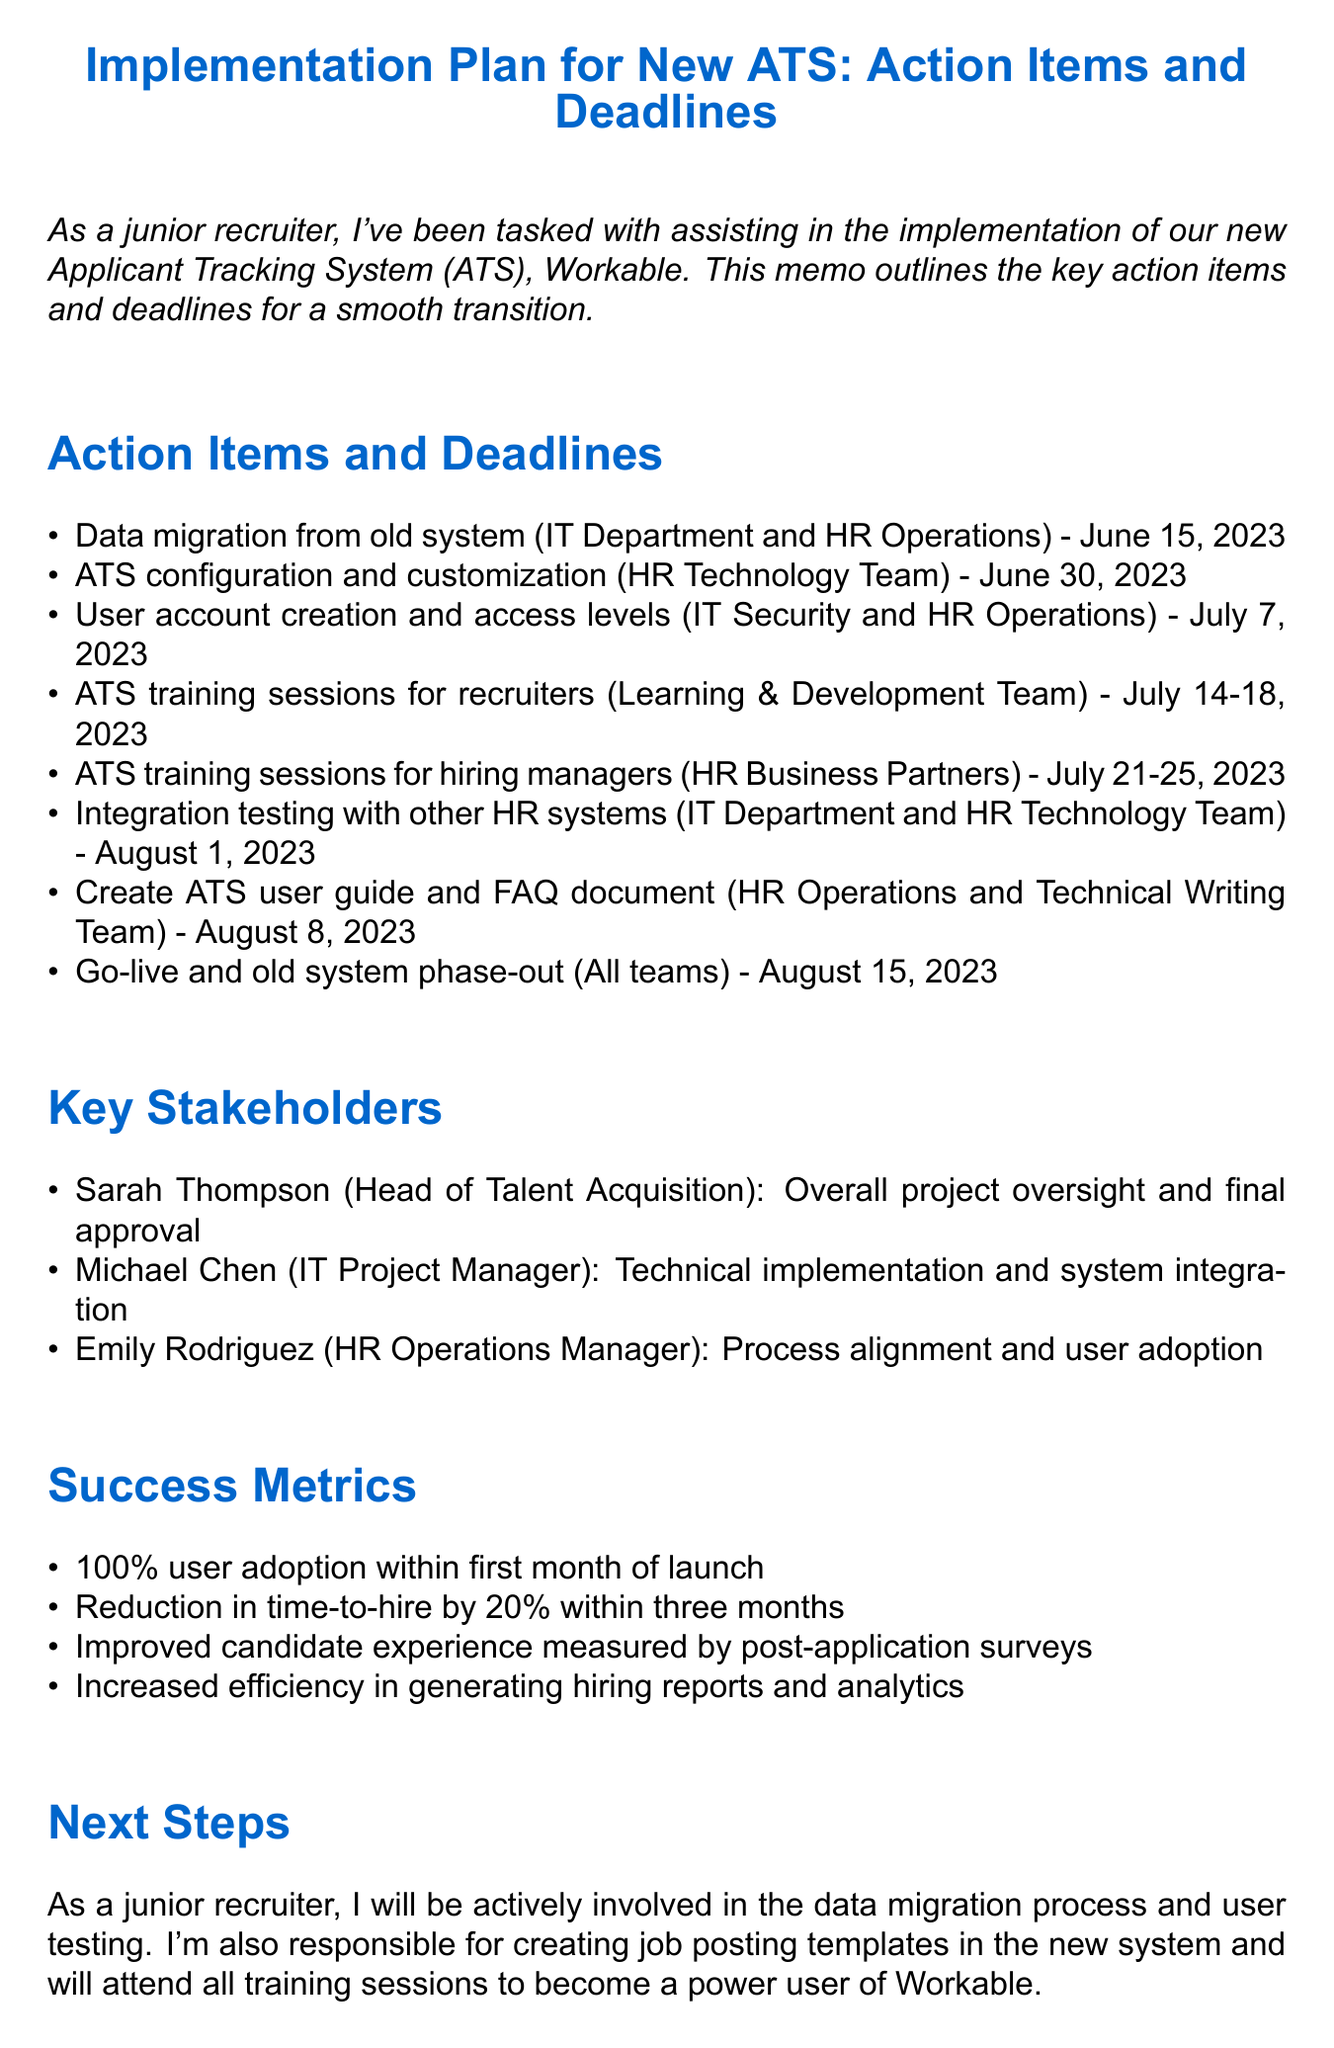What is the title of the memo? The title of the memo is presented at the beginning of the document as the main heading.
Answer: Implementation Plan for New ATS: Action Items and Deadlines Who is responsible for data migration from the old system? The assignee for data migration is specified in the action items section of the memo.
Answer: IT Department and HR Operations What is the deadline for ATS configuration and customization? The deadline is provided in the action items section along with the specific task.
Answer: June 30, 2023 What are the success metrics for the ATS implementation? The metrics are listed in the success metrics section, which outlines the goals for the implementation.
Answer: 100% user adoption within first month of launch Which team is conducting ATS training sessions for recruiters? The training sessions for recruiters are assigned to a specific team mentioned in the action items.
Answer: Learning & Development Team What is the role of Sarah Thompson in this project? The responsibilities of key stakeholders are outlined, specifically for Sarah Thompson.
Answer: Overall project oversight and final approval How many days are allocated for ATS training sessions for hiring managers? The deadline for training sessions is provided in the action items along with the number of days.
Answer: Five days What is the final deadline for the ATS go-live? The go-live date is included among the key action items in the document.
Answer: August 15, 2023 In what month is integration testing scheduled? The deadline for integration testing is specified in the action items, indicating the month of execution.
Answer: August 